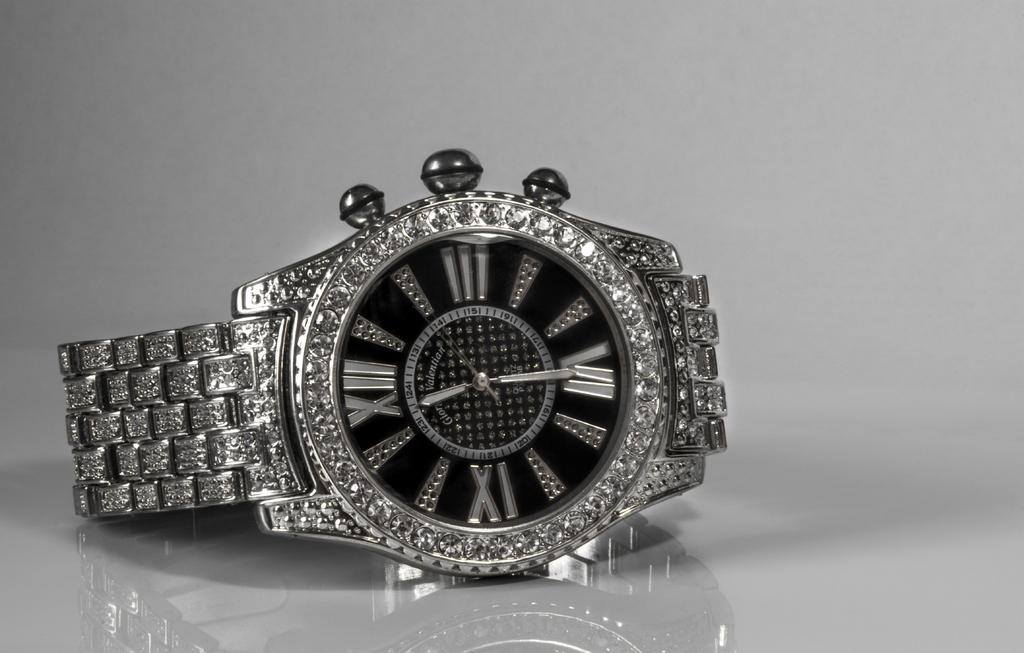<image>
Offer a succinct explanation of the picture presented. A silver wrist watch showing 11:30 placed on a reflective surface. 